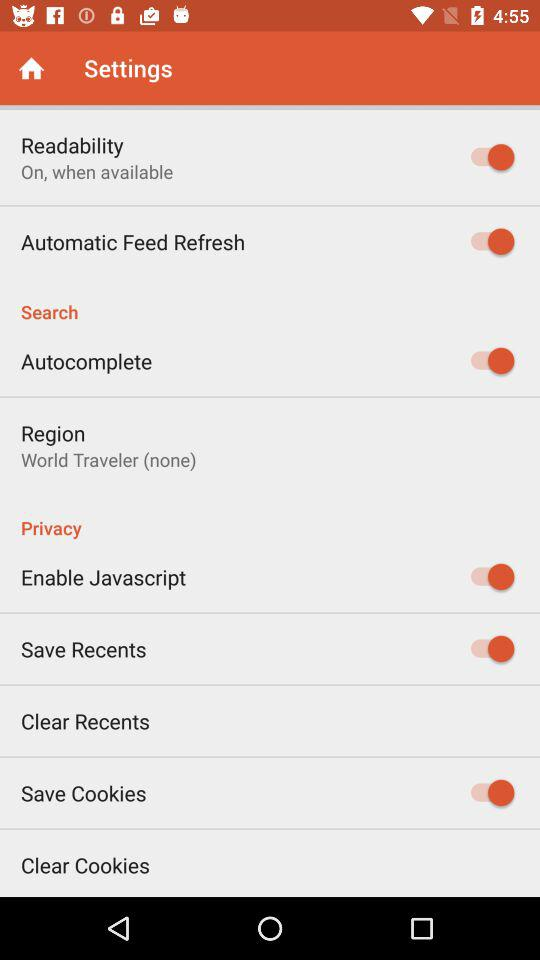What is the setting for readability? The setting is "On, when available". 